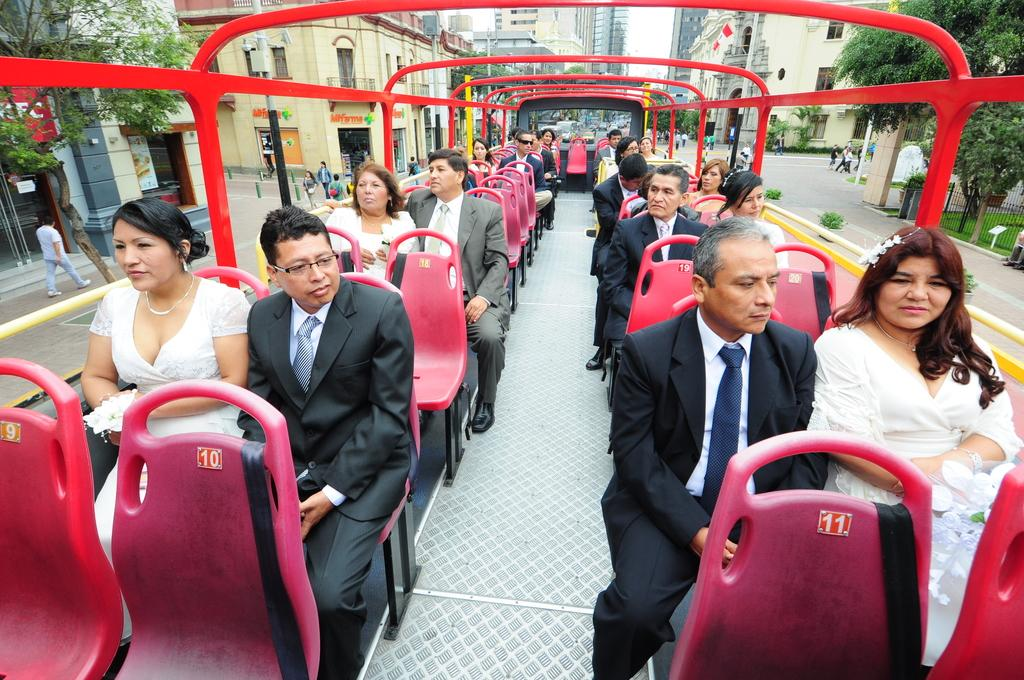Provide a one-sentence caption for the provided image. A man in a black suit sits behind a red seat labelled number 10. 